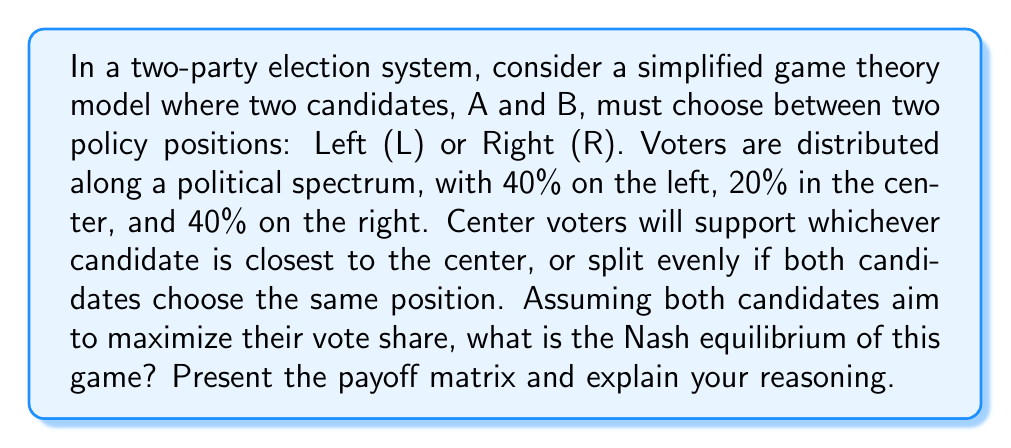Teach me how to tackle this problem. To solve this problem, we need to follow these steps:

1. Construct the payoff matrix:
   Let's create a payoff matrix showing the percentage of votes each candidate would receive in each scenario.

   $$
   \begin{array}{c|c|c}
    & B \text{ chooses L} & B \text{ chooses R} \\
   \hline
   A \text{ chooses L} & (50, 50) & (60, 40) \\
   \hline
   A \text{ chooses R} & (40, 60) & (50, 50)
   \end{array}
   $$

   Explanation of payoffs:
   - If both choose L or both choose R: They split the vote 50-50
   - If A chooses L and B chooses R: A gets 40% (left) + 20% (center) = 60%, B gets 40% (right)
   - If A chooses R and B chooses L: B gets 40% (left) + 20% (center) = 60%, A gets 40% (right)

2. Analyze the strategic choices:
   - If B chooses L, A's best response is to choose L (50 > 40)
   - If B chooses R, A's best response is to choose L (60 > 50)
   - If A chooses L, B's best response is to choose L (50 > 40)
   - If A chooses R, B's best response is to choose L (60 > 50)

3. Identify the Nash equilibrium:
   A Nash equilibrium occurs when neither player can unilaterally improve their outcome by changing their strategy. In this case, we can see that (L, L) is a Nash equilibrium because neither player can improve their payoff by switching to R.

4. Check for other equilibria:
   There are no other Nash equilibria in this game. (R, R) is not stable because either player could improve their payoff by switching to L. The asymmetric outcomes (L, R) and (R, L) are not equilibria because the player choosing R could always improve by switching to L.

Therefore, the unique Nash equilibrium of this game is for both candidates to choose the Left (L) position.
Answer: The Nash equilibrium of this game is (L, L), where both candidates choose the Left position. 